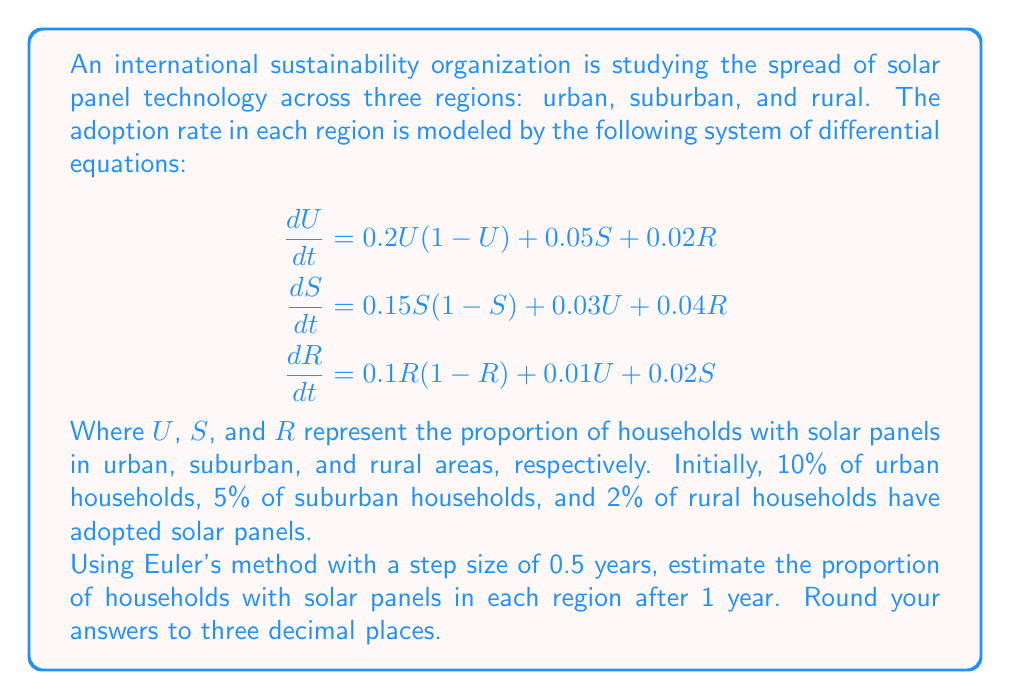Solve this math problem. To solve this problem using Euler's method, we'll follow these steps:

1) Euler's method is given by the formula:
   $y_{n+1} = y_n + h \cdot f(t_n, y_n)$
   where $h$ is the step size and $f(t_n, y_n)$ is the right-hand side of the differential equation.

2) We have three equations, so we'll apply Euler's method to each:
   $U_{n+1} = U_n + h \cdot (0.2U_n(1-U_n) + 0.05S_n + 0.02R_n)$
   $S_{n+1} = S_n + h \cdot (0.15S_n(1-S_n) + 0.03U_n + 0.04R_n)$
   $R_{n+1} = R_n + h \cdot (0.1R_n(1-R_n) + 0.01U_n + 0.02S_n)$

3) Given:
   - Initial values: $U_0 = 0.10$, $S_0 = 0.05$, $R_0 = 0.02$
   - Step size: $h = 0.5$ years
   - We need to calculate for 1 year, so we'll do 2 steps

4) First step ($n = 0$):
   $U_1 = 0.10 + 0.5 \cdot (0.2 \cdot 0.10 \cdot 0.90 + 0.05 \cdot 0.05 + 0.02 \cdot 0.02) = 0.11175$
   $S_1 = 0.05 + 0.5 \cdot (0.15 \cdot 0.05 \cdot 0.95 + 0.03 \cdot 0.10 + 0.04 \cdot 0.02) = 0.05605$
   $R_1 = 0.02 + 0.5 \cdot (0.1 \cdot 0.02 \cdot 0.98 + 0.01 \cdot 0.10 + 0.02 \cdot 0.05) = 0.02196$

5) Second step ($n = 1$):
   $U_2 = 0.11175 + 0.5 \cdot (0.2 \cdot 0.11175 \cdot 0.88825 + 0.05 \cdot 0.05605 + 0.02 \cdot 0.02196) = 0.12414$
   $S_2 = 0.05605 + 0.5 \cdot (0.15 \cdot 0.05605 \cdot 0.94395 + 0.03 \cdot 0.11175 + 0.04 \cdot 0.02196) = 0.06247$
   $R_2 = 0.02196 + 0.5 \cdot (0.1 \cdot 0.02196 \cdot 0.97804 + 0.01 \cdot 0.11175 + 0.02 \cdot 0.05605) = 0.02401$

6) Rounding to three decimal places:
   $U_2 = 0.124$, $S_2 = 0.062$, $R_2 = 0.024$
Answer: After 1 year:
Urban: 0.124
Suburban: 0.062
Rural: 0.024 